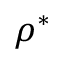Convert formula to latex. <formula><loc_0><loc_0><loc_500><loc_500>\rho ^ { * }</formula> 